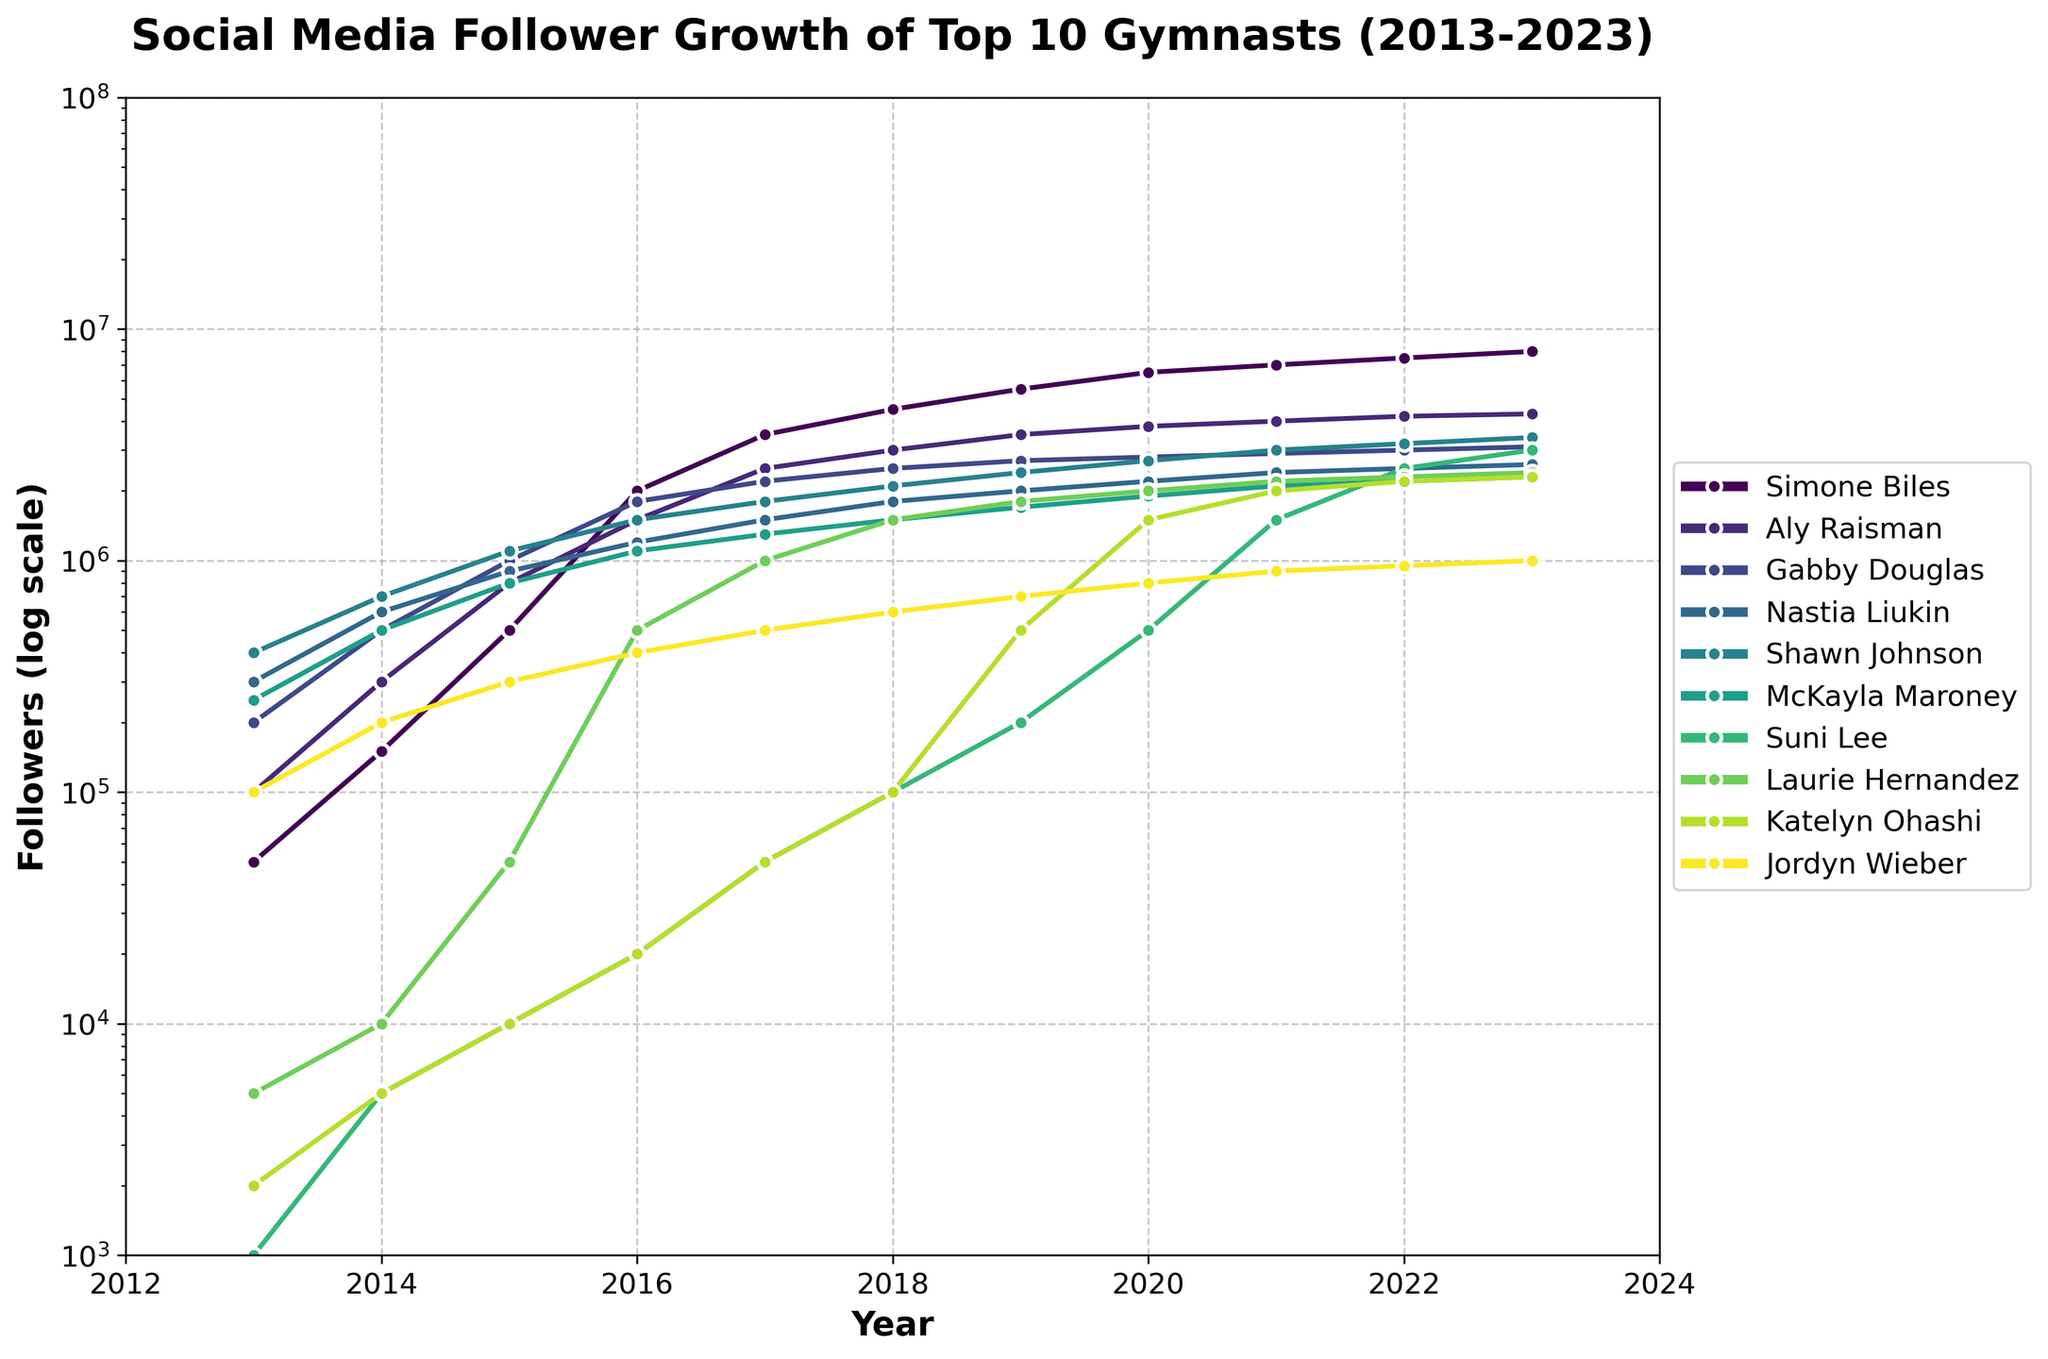What is the difference in followers between Simone Biles and Aly Raisman in 2023? Referencing the chart, Simone Biles has 8,000,000 followers in 2023, while Aly Raisman has 4,300,000 followers. The difference is 8,000,000 - 4,300,000 = 3,700,000
Answer: 3,700,000 Which gymnast experienced the most significant follower growth between 2013 and 2023? By examining the chart, Simone Biles shows the most significant growth, starting with 50,000 followers in 2013 and reaching 8,000,000 in 2023. The growth is calculated as 8,000,000 - 50,000 = 7,950,000
Answer: Simone Biles Who had more followers in 2020, McKayla Maroney or Laurie Hernandez? Checking the graph, McKayla Maroney had around 1,900,000 followers, while Laurie Hernandez had 2,000,000 followers in 2020. Thus, Laurie Hernandez had more followers
Answer: Laurie Hernandez In which year did Suni Lee's social media followers reach 1,000,000 for the first time? From the figure, Suni Lee's followers first reached around 1,000,000 in 2021
Answer: 2021 Among the top 10 gymnasts, whose follower count showed the least variation from 2013 to 2023? Observing the chart, Jordyn Wieber's followers showed a relatively consistent and steady growth pattern compared to others. The follower count increased gradually from 100,000 in 2013 to 1,000,000 in 2023
Answer: Jordyn Wieber How many gymnasts had 2,000,000 or more followers by 2023? Checking the chart, Simone Biles, Aly Raisman, Gabby Douglas, Nastia Liukin, Shawn Johnson, Suni Lee, Laurie Hernandez, and Katelyn Ohashi each had 2,000,000 or more followers by 2023. In total, that's eight gymnasts
Answer: 8 Who gained more followers between 2016 and 2020, Nastia Liukin or Shawn Johnson? From the chart, Nastia Liukin's followers increased from 1,200,000 in 2016 to 2,200,000 in 2020. Shawn Johnson's followers increased from 1,500,000 in 2016 to 2,700,000 in 2020. Thus, Shawn Johnson gained more followers: 2,700,000 - 1,500,000 = 1,200,000, compared to Nastia Liukin's  2,200,000 - 1,200,000 = 1,000,000
Answer: Shawn Johnson What is the average follower count of Suni Lee from 2013 to 2023? Suni Lee's follower counts for the years 2013-2023 are 1,000, 5,000, 10,000, 20,000, 50,000, 100,000, 200,000, 500,000, 1,500,000, 2,500,000, and 3,000,000. Summing these up: 1,000 + 5,000 + 10,000 + 20,000 + 50,000 + 100,000 + 200,000 + 500,000 + 1,500,000 + 2,500,000 + 3,000,000 = 7,886,000. Dividing by the 11 years, the average is approximately 7,886,000 / 11 ≈ 716,000
Answer: 716,000 